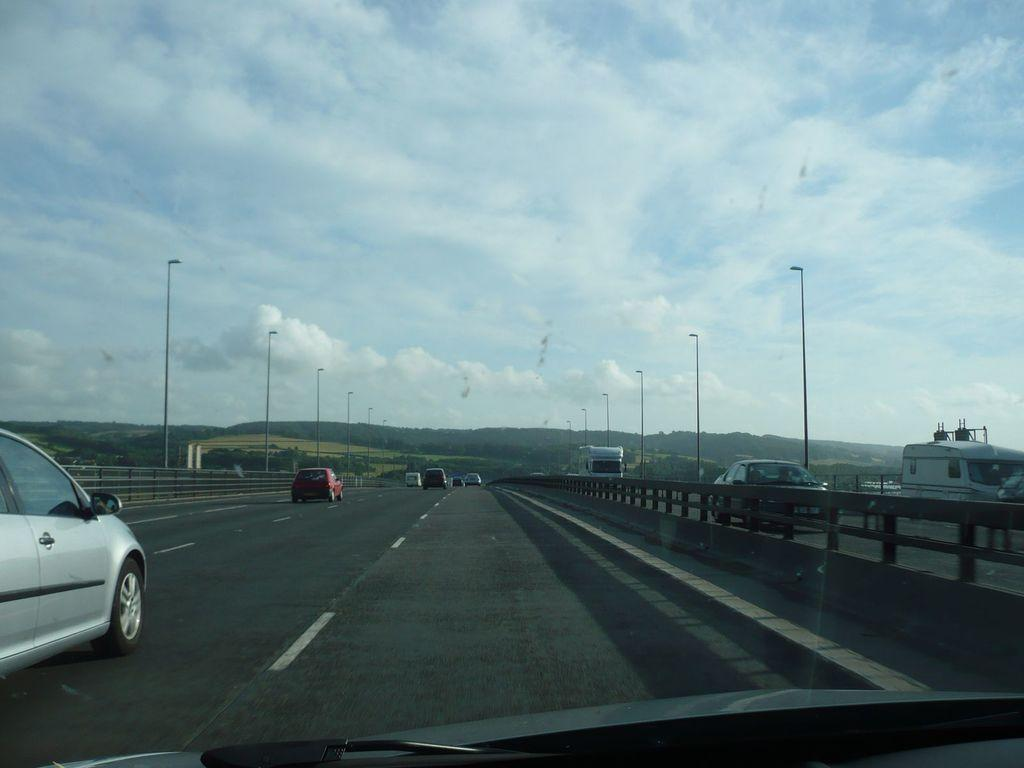What can be seen on the road in the image? There are vehicles on the road in the image. What type of barrier is present in the image? There is a fence in the image. What structures are providing illumination in the image? There are light poles in the image. What type of vegetation is visible in the image? There are trees in the image. What geographical feature can be seen in the background of the image? There are mountains in the image. What is visible in the sky at the top of the image? There are clouds in the sky at the top of the image. How much tax is being paid on the vehicles in the image? There is no information about taxes being paid on the vehicles in the image. What type of stamp is visible on the mountains in the image? There are no stamps present on the mountains in the image. 